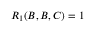Convert formula to latex. <formula><loc_0><loc_0><loc_500><loc_500>R _ { 1 } ( B , B , C ) = 1</formula> 